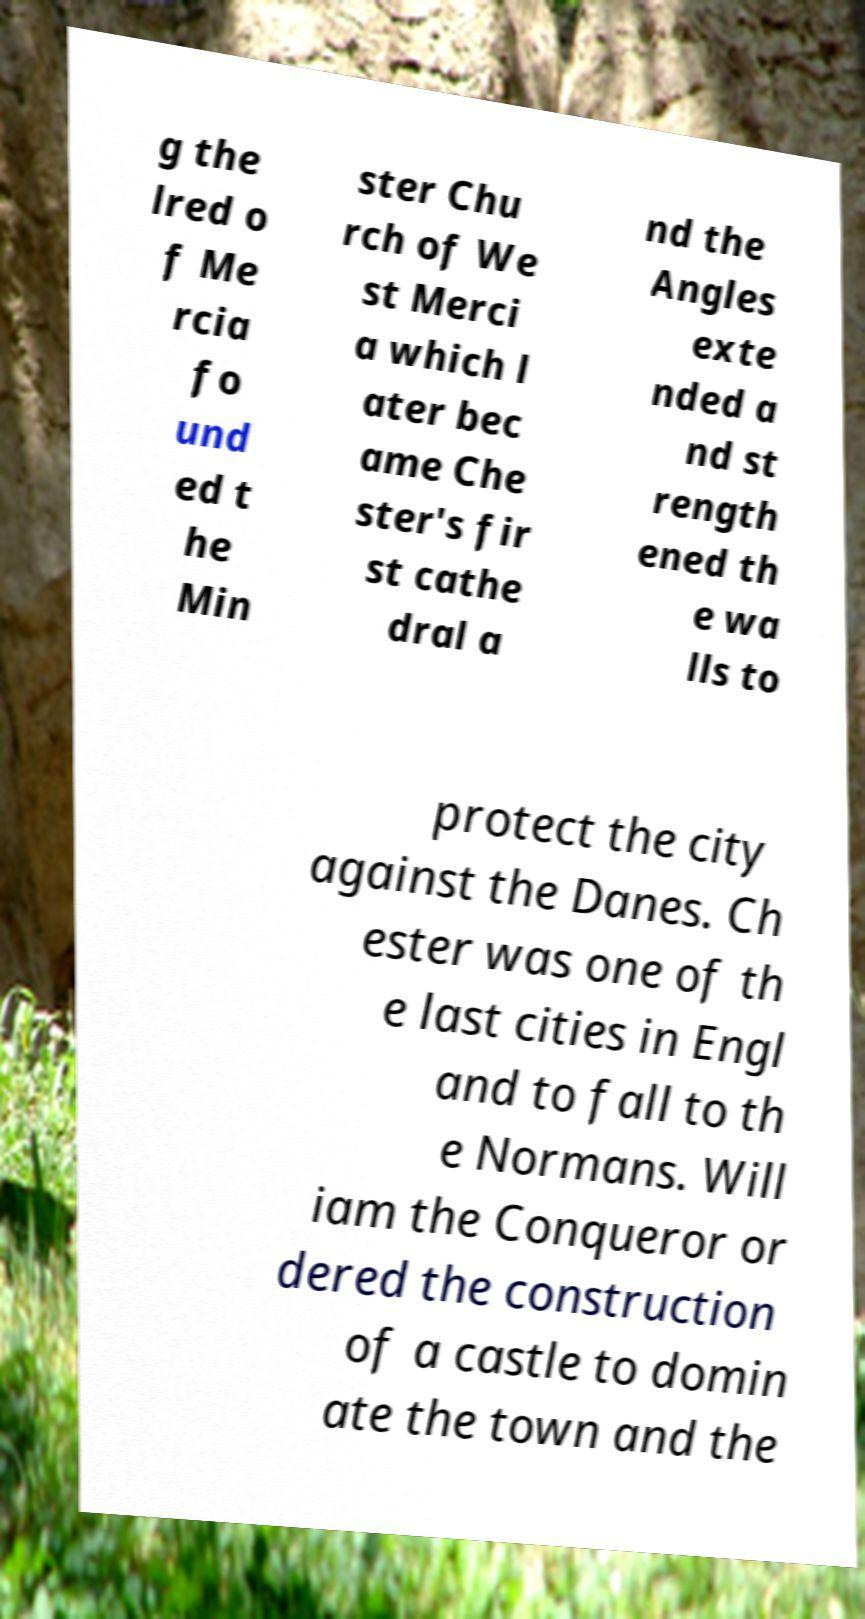Can you read and provide the text displayed in the image?This photo seems to have some interesting text. Can you extract and type it out for me? g the lred o f Me rcia fo und ed t he Min ster Chu rch of We st Merci a which l ater bec ame Che ster's fir st cathe dral a nd the Angles exte nded a nd st rength ened th e wa lls to protect the city against the Danes. Ch ester was one of th e last cities in Engl and to fall to th e Normans. Will iam the Conqueror or dered the construction of a castle to domin ate the town and the 